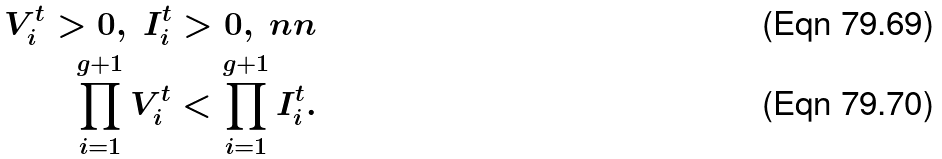<formula> <loc_0><loc_0><loc_500><loc_500>V _ { i } ^ { t } > 0 , \ I _ { i } ^ { t } > 0 , \ n n \\ \prod _ { i = 1 } ^ { g + 1 } V _ { i } ^ { t } < \prod _ { i = 1 } ^ { g + 1 } I _ { i } ^ { t } .</formula> 